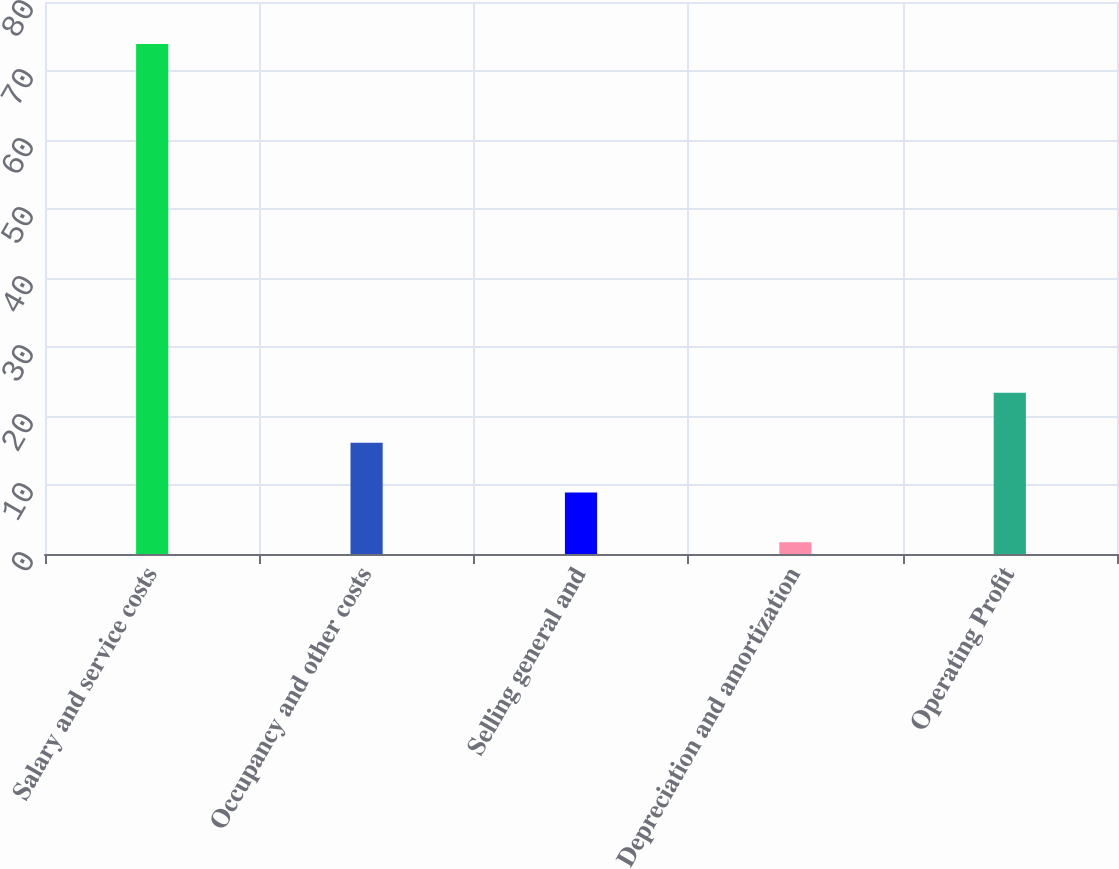<chart> <loc_0><loc_0><loc_500><loc_500><bar_chart><fcel>Salary and service costs<fcel>Occupancy and other costs<fcel>Selling general and<fcel>Depreciation and amortization<fcel>Operating Profit<nl><fcel>73.9<fcel>16.14<fcel>8.92<fcel>1.7<fcel>23.36<nl></chart> 